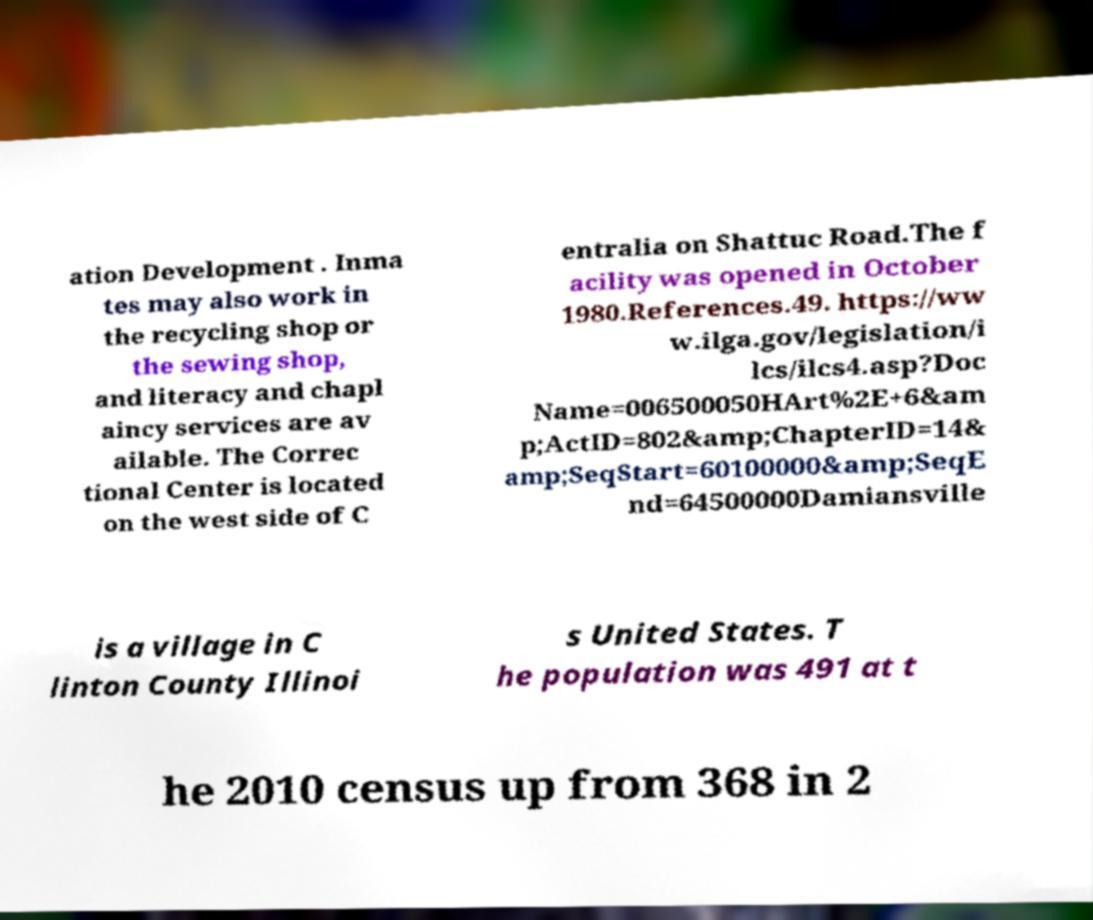For documentation purposes, I need the text within this image transcribed. Could you provide that? ation Development . Inma tes may also work in the recycling shop or the sewing shop, and literacy and chapl aincy services are av ailable. The Correc tional Center is located on the west side of C entralia on Shattuc Road.The f acility was opened in October 1980.References.49. https://ww w.ilga.gov/legislation/i lcs/ilcs4.asp?Doc Name=006500050HArt%2E+6&am p;ActID=802&amp;ChapterID=14& amp;SeqStart=60100000&amp;SeqE nd=64500000Damiansville is a village in C linton County Illinoi s United States. T he population was 491 at t he 2010 census up from 368 in 2 